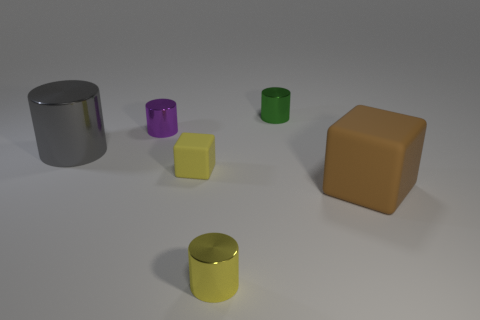Which object is the largest in the image? The largest object in the image is the orange cube on the right side. It has visibly larger dimensions compared to the other objects present. How does the lighting affect the appearance of the objects? The lighting in the image creates soft shadows and highlights on the objects, enhancing their three-dimensional appearance and emphasizing their shapes and textures. It gives a more realistic and dynamic view of the scene. 